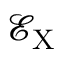<formula> <loc_0><loc_0><loc_500><loc_500>\mathcal { E } _ { X }</formula> 